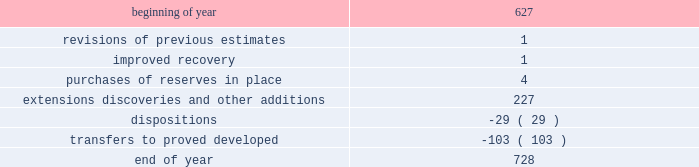During 2014 , 2013 and 2012 , netherland , sewell & associates , inc .
( "nsai" ) prepared a certification of the prior year's reserves for the alba field in e.g .
The nsai summary reports are filed as an exhibit to this annual report on form 10-k .
Members of the nsai team have multiple years of industry experience , having worked for large , international oil and gas companies before joining nsai .
The senior technical advisor has over 35 years of practical experience in petroleum geosciences , with over 15 years experience in the estimation and evaluation of reserves .
The second team member has over 10 years of practical experience in petroleum engineering , with 5 years experience in the estimation and evaluation of reserves .
Both are registered professional engineers in the state of texas .
Ryder scott company ( "ryder scott" ) also performed audits of the prior years' reserves of several of our fields in 2014 , 2013 and 2012 .
Their summary reports are filed as exhibits to this annual report on form 10-k .
The team lead for ryder scott has over 20 years of industry experience , having worked for a major international oil and gas company before joining ryder scott .
He is a member of spe , where he served on the oil and gas reserves committee , and is a registered professional engineer in the state of texas .
Changes in proved undeveloped reserves as of december 31 , 2014 , 728 mmboe of proved undeveloped reserves were reported , an increase of 101 mmboe from december 31 , 2013 .
The table shows changes in total proved undeveloped reserves for 2014 : ( mmboe ) .
Significant additions to proved undeveloped reserves during 2014 included 121 mmboe in the eagle ford and 61 mmboe in the bakken shale plays due to development drilling .
Transfers from proved undeveloped to proved developed reserves included 67 mmboe in the eagle ford , 26 mmboe in the bakken and 1 mmboe in the oklahoma resource basins due to development drilling and completions .
Costs incurred in 2014 , 2013 and 2012 relating to the development of proved undeveloped reserves , were $ 3149 million , $ 2536 million and $ 1995 million .
A total of 102 mmboe was booked as extensions , discoveries or other additions due to the application of reliable technology .
Technologies included statistical analysis of production performance , decline curve analysis , pressure and rate transient analysis , reservoir simulation and volumetric analysis .
The statistical nature of production performance coupled with highly certain reservoir continuity or quality within the reliable technology areas and sufficient proved undeveloped locations establish the reasonable certainty criteria required for booking proved reserves .
Projects can remain in proved undeveloped reserves for extended periods in certain situations such as large development projects which take more than five years to complete , or the timing of when additional gas compression is needed .
Of the 728 mmboe of proved undeveloped reserves at december 31 , 2014 , 19 percent of the volume is associated with projects that have been included in proved reserves for more than five years .
The majority of this volume is related to a compression project in e.g .
That was sanctioned by our board of directors in 2004 .
The timing of the installation of compression is being driven by the reservoir performance with this project intended to maintain maximum production levels .
Performance of this field since the board sanctioned the project has far exceeded expectations .
Estimates of initial dry gas in place increased by roughly 10 percent between 2004 and 2010 .
During 2012 , the compression project received the approval of the e.g .
Government , allowing design and planning work to progress towards implementation , with completion expected by mid-2016 .
The other component of alba proved undeveloped reserves is an infill well approved in 2013 and to be drilled in the second quarter of 2015 .
Proved undeveloped reserves for the north gialo development , located in the libyan sahara desert , were booked for the first time in 2010 .
This development , which is anticipated to take more than five years to develop , is executed by the operator and encompasses a multi-year drilling program including the design , fabrication and installation of extensive liquid handling and gas recycling facilities .
Anecdotal evidence from similar development projects in the region lead to an expected project execution time frame of more than five years from the time the reserves were initially booked .
Interruptions associated with the civil unrest in 2011 and third-party labor strikes and civil unrest in 2013-2014 have also extended the project duration .
As of december 31 , 2014 , future development costs estimated to be required for the development of proved undeveloped crude oil and condensate , ngls , natural gas and synthetic crude oil reserves related to continuing operations for the years 2015 through 2019 are projected to be $ 2915 million , $ 2598 million , $ 2493 million , $ 2669 million and $ 2745 million. .
By how much did undeveloped reserves increase throughout 2014 ff1f? 
Computations: ((728 - 627) / 728)
Answer: 0.13874. 